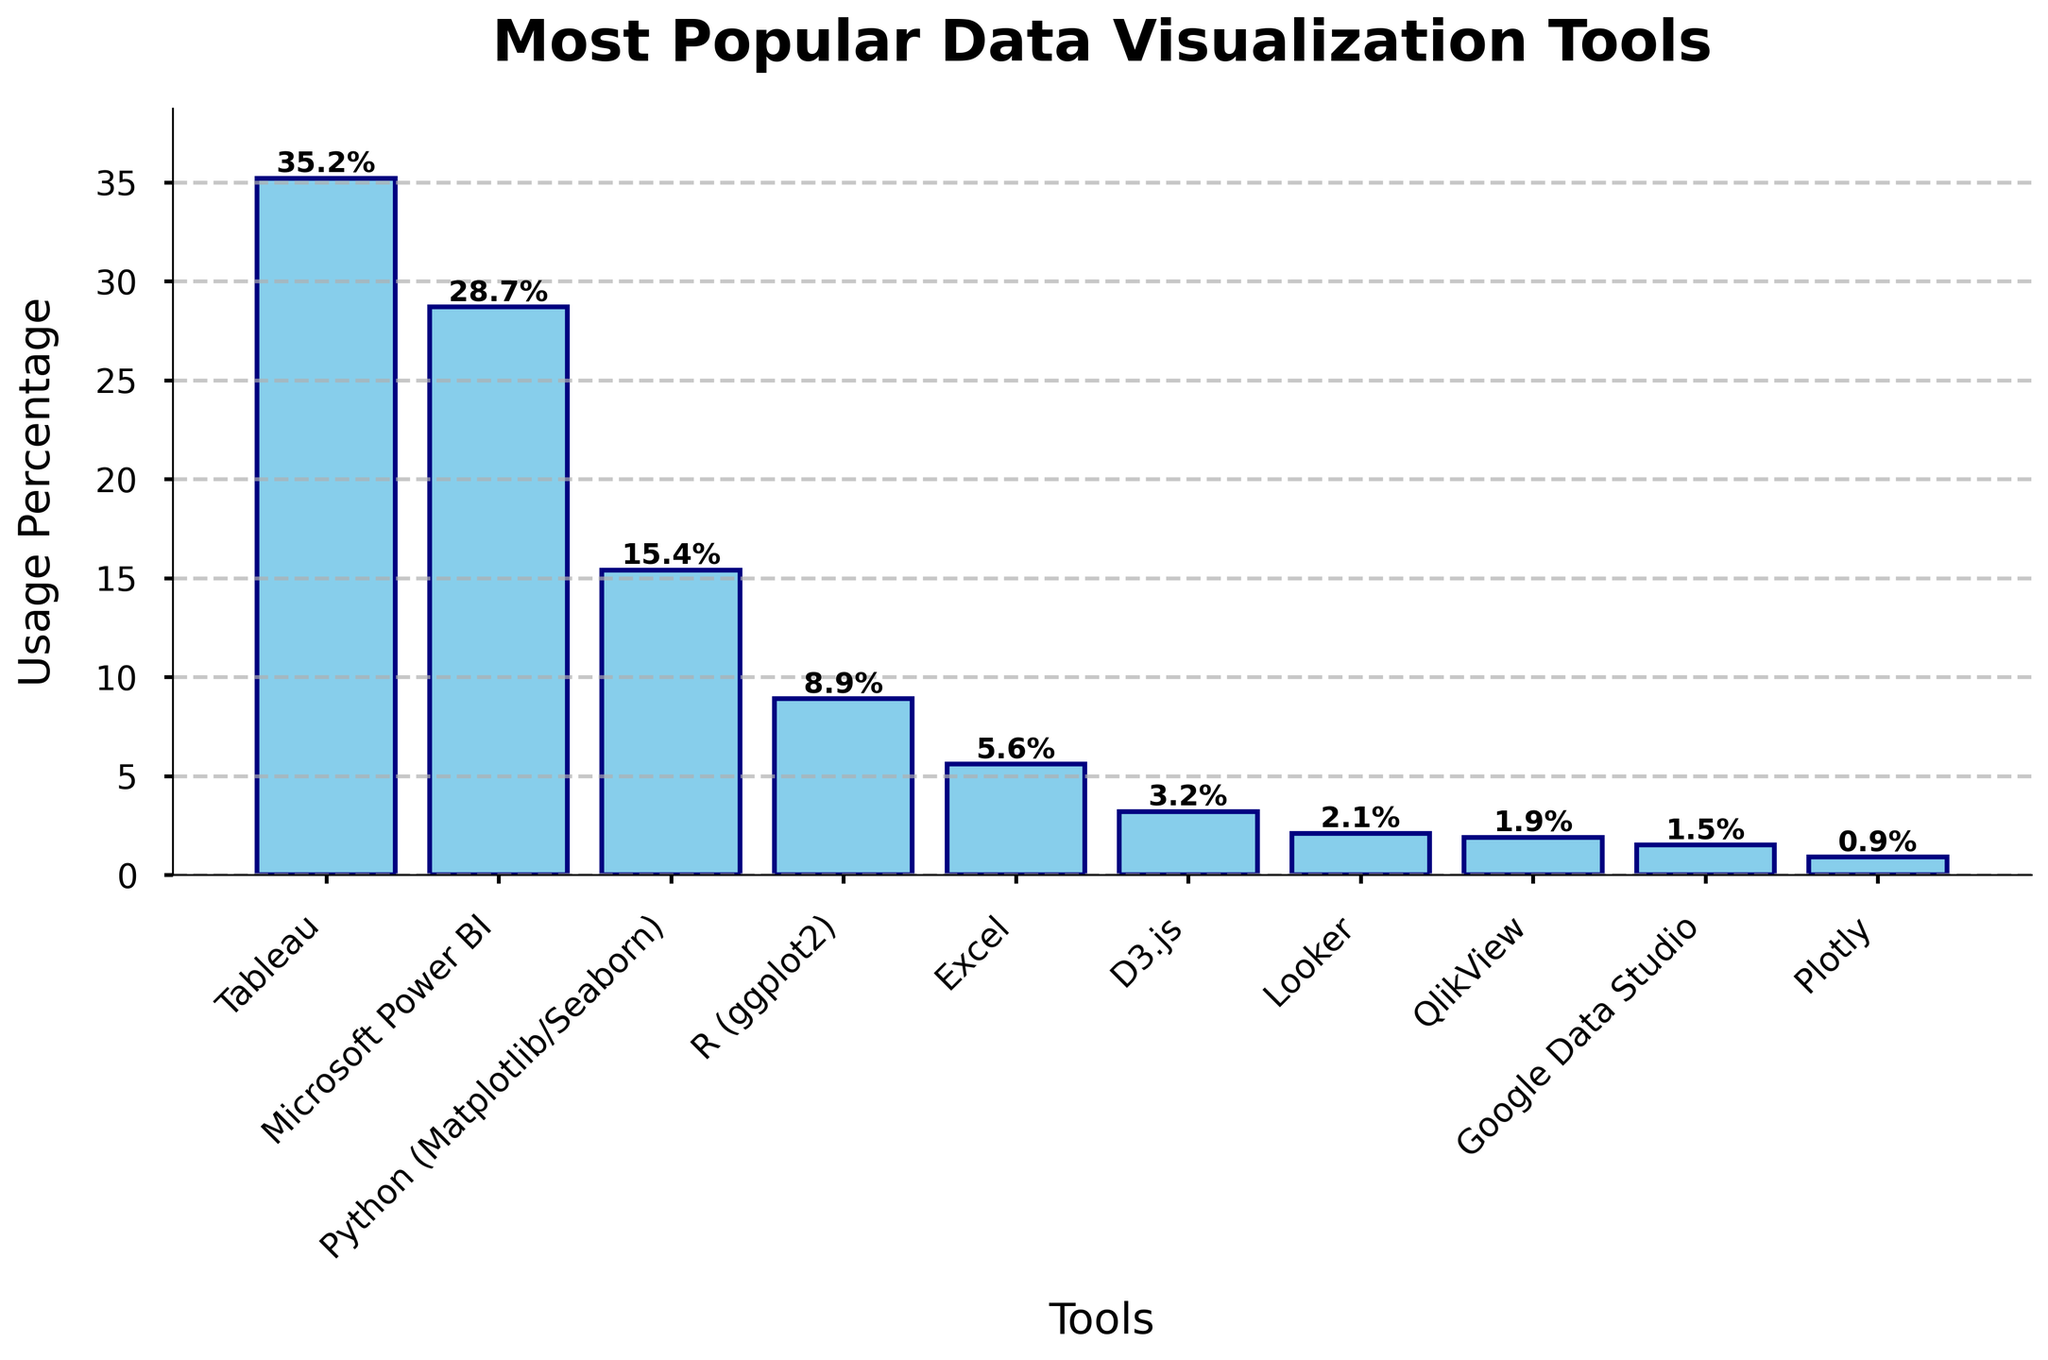What's the most popular data visualization tool? The tool with the highest usage percentage is Tableau at 35.2%.
Answer: Tableau Which tool is more popular, Microsoft Power BI or Python (Matplotlib/Seaborn)? Compare the usage percentages: Microsoft Power BI has 28.7% and Python has 15.4%. Therefore, Microsoft Power BI is more popular.
Answer: Microsoft Power BI What is the combined usage percentage of Tableau and Microsoft Power BI? Add their usage percentages: 35.2% (Tableau) + 28.7% (Microsoft Power BI) = 63.9%.
Answer: 63.9% How does the usage percentage of Python (Matplotlib/Seaborn) compare to that of R (ggplot2)? Python (Matplotlib/Seaborn) has a usage percentage of 15.4%, while R (ggplot2) has 8.9%. Python is higher than R.
Answer: Python Which tool has a usage percentage closest to 10%? Check the usage percentages: Tableau (35.2%), Microsoft Power BI (28.7%), Python (15.4%), R (8.9%), Excel (5.6%), D3.js (3.2%), Looker (2.1%), QlikView (1.9%), Google Data Studio (1.5%), Plotly (0.9%). R (ggplot2) at 8.9% is closest to 10%.
Answer: R (ggplot2) What is the total usage percentage of the bottom four tools? Sum the usage percentages of the bottom four tools: Looker (2.1%) + QlikView (1.9%) + Google Data Studio (1.5%) + Plotly (0.9%) = 6.4%.
Answer: 6.4% What percentage of professionals use a tool other than Tableau, Microsoft Power BI, or Python? Subtract the usage of Tableau, Microsoft Power BI, and Python from 100%: 100% - (35.2% + 28.7% + 15.4%) = 20.7%.
Answer: 20.7% What is the difference in usage percentage between the most popular tool and the least popular tool? Subtract the least popular tool's percentage from the most popular tool's percentage: 35.2% (Tableau) - 0.9% (Plotly) = 34.3%.
Answer: 34.3% Which tools have a usage percentage below 5%? Check which tools have a usage percentage less than 5%: D3.js (3.2%), Looker (2.1%), QlikView (1.9%), Google Data Studio (1.5%), and Plotly (0.9%).
Answer: D3.js, Looker, QlikView, Google Data Studio, Plotly How many tools have a usage percentage higher than 20%? Count the tools with a usage percentage above 20%: Tableau (35.2%) and Microsoft Power BI (28.7%), making a total of 2 tools.
Answer: 2 